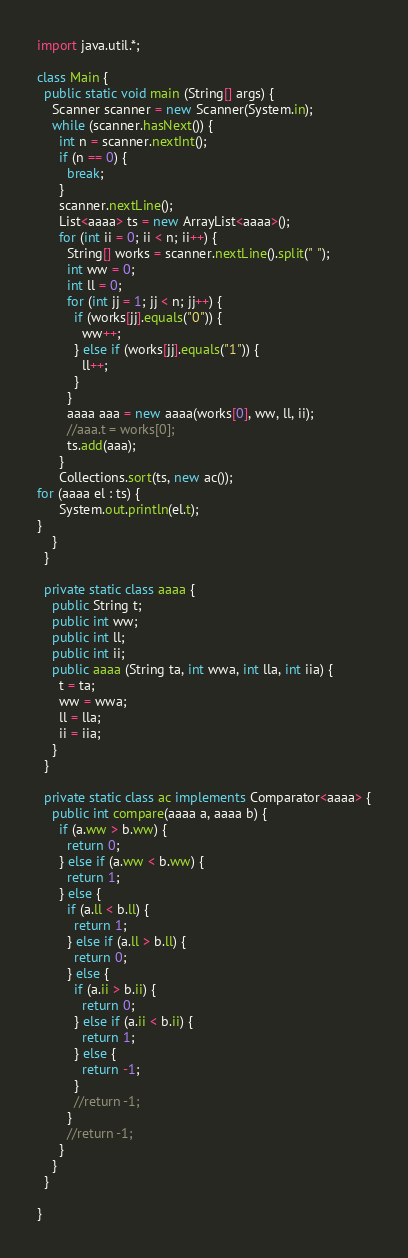<code> <loc_0><loc_0><loc_500><loc_500><_Java_>import java.util.*;

class Main {
  public static void main (String[] args) {
    Scanner scanner = new Scanner(System.in);
    while (scanner.hasNext()) {
      int n = scanner.nextInt();
      if (n == 0) {
        break;
      }
      scanner.nextLine();
      List<aaaa> ts = new ArrayList<aaaa>();
      for (int ii = 0; ii < n; ii++) {
        String[] works = scanner.nextLine().split(" ");
        int ww = 0;
        int ll = 0;
        for (int jj = 1; jj < n; jj++) {
          if (works[jj].equals("0")) {
            ww++;
          } else if (works[jj].equals("1")) {
            ll++;
          }
        }
        aaaa aaa = new aaaa(works[0], ww, ll, ii);
        //aaa.t = works[0];
        ts.add(aaa);
      }
      Collections.sort(ts, new ac());
for (aaaa el : ts) {
      System.out.println(el.t);
}
    }
  }

  private static class aaaa {
    public String t;
    public int ww;
    public int ll;
    public int ii;
    public aaaa (String ta, int wwa, int lla, int iia) {
      t = ta;
      ww = wwa;
      ll = lla;
      ii = iia;
    }
  }

  private static class ac implements Comparator<aaaa> {
    public int compare(aaaa a, aaaa b) {
      if (a.ww > b.ww) {
        return 0;
      } else if (a.ww < b.ww) {
        return 1;
      } else {
        if (a.ll < b.ll) {
          return 1;
        } else if (a.ll > b.ll) {
          return 0;
        } else {
          if (a.ii > b.ii) {
            return 0;
          } else if (a.ii < b.ii) {
            return 1;
          } else {
            return -1;
          }
          //return -1;
        }
        //return -1;
      }
    }
  }

}</code> 